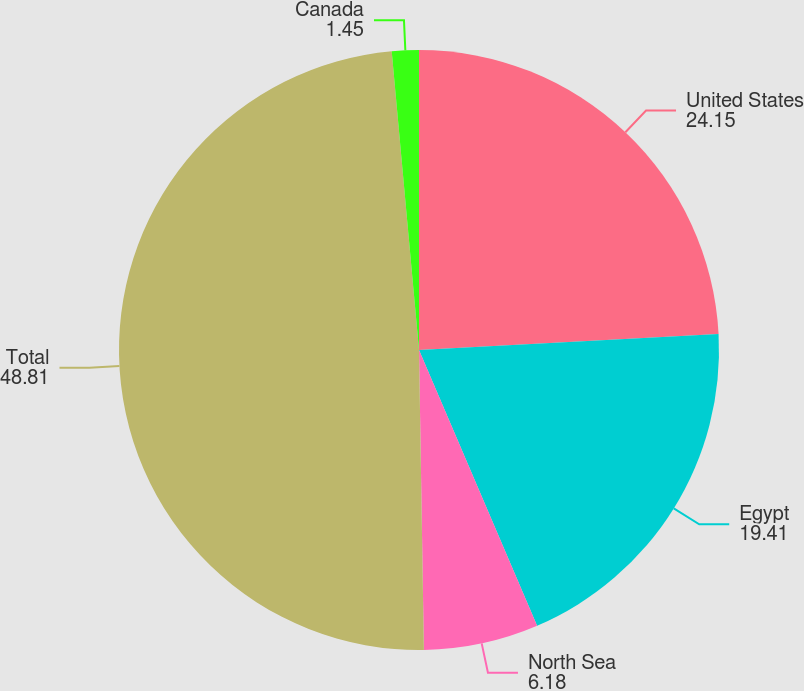<chart> <loc_0><loc_0><loc_500><loc_500><pie_chart><fcel>United States<fcel>Egypt<fcel>North Sea<fcel>Total<fcel>Canada<nl><fcel>24.15%<fcel>19.41%<fcel>6.18%<fcel>48.81%<fcel>1.45%<nl></chart> 